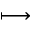<formula> <loc_0><loc_0><loc_500><loc_500>\longmapsto</formula> 